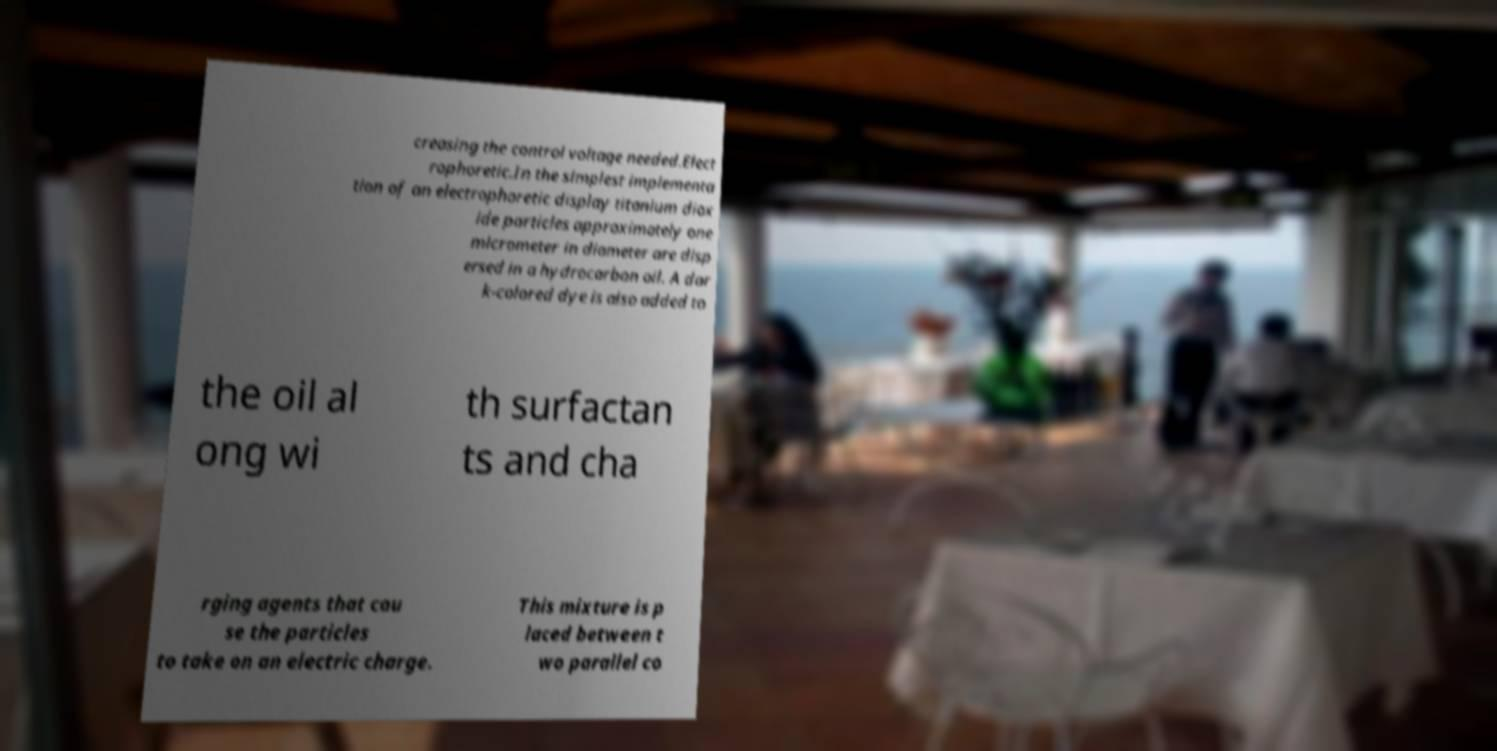There's text embedded in this image that I need extracted. Can you transcribe it verbatim? creasing the control voltage needed.Elect rophoretic.In the simplest implementa tion of an electrophoretic display titanium diox ide particles approximately one micrometer in diameter are disp ersed in a hydrocarbon oil. A dar k-colored dye is also added to the oil al ong wi th surfactan ts and cha rging agents that cau se the particles to take on an electric charge. This mixture is p laced between t wo parallel co 